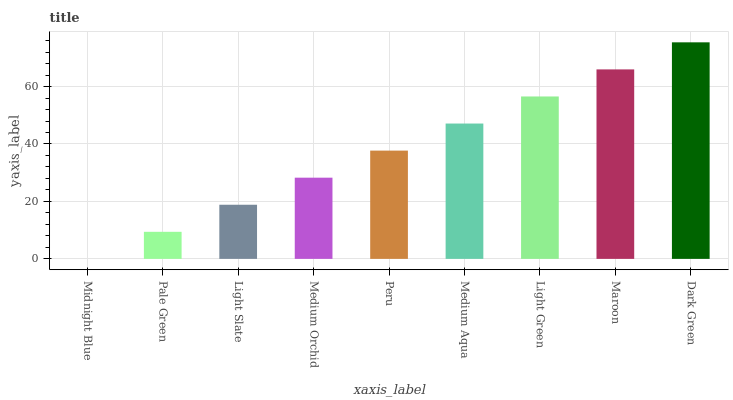Is Midnight Blue the minimum?
Answer yes or no. Yes. Is Dark Green the maximum?
Answer yes or no. Yes. Is Pale Green the minimum?
Answer yes or no. No. Is Pale Green the maximum?
Answer yes or no. No. Is Pale Green greater than Midnight Blue?
Answer yes or no. Yes. Is Midnight Blue less than Pale Green?
Answer yes or no. Yes. Is Midnight Blue greater than Pale Green?
Answer yes or no. No. Is Pale Green less than Midnight Blue?
Answer yes or no. No. Is Peru the high median?
Answer yes or no. Yes. Is Peru the low median?
Answer yes or no. Yes. Is Light Green the high median?
Answer yes or no. No. Is Light Slate the low median?
Answer yes or no. No. 